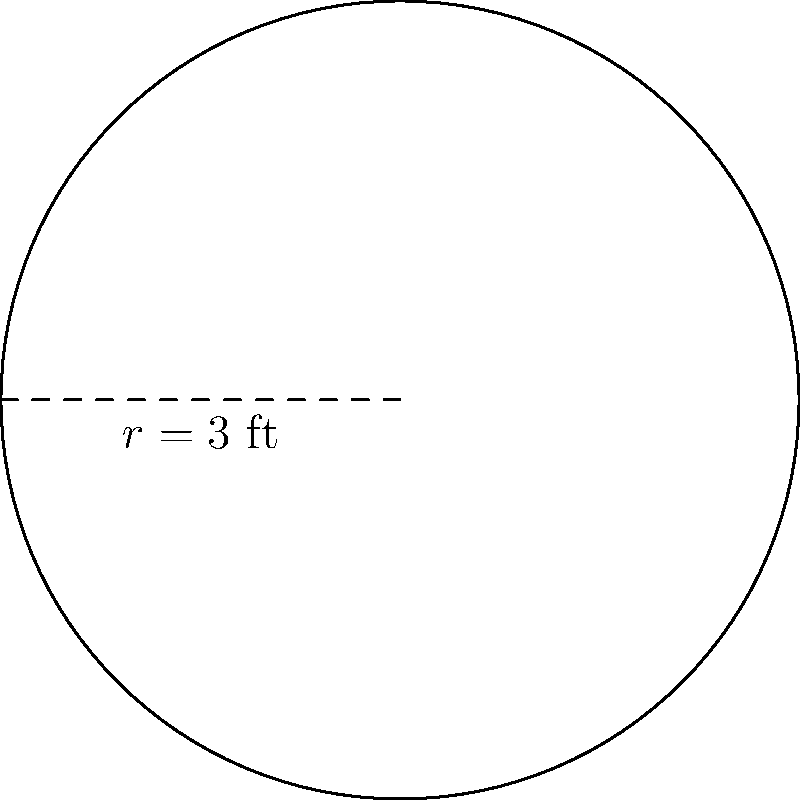As the community center staff member, you need to determine the area of a circular table for the English language classroom. The table has a radius of 3 feet. Calculate the area of the table in square feet, using $\pi \approx 3.14$. To find the area of a circular table, we'll use the formula for the area of a circle:

1. The formula for the area of a circle is:
   $A = \pi r^2$

2. We're given that the radius $r = 3$ feet and $\pi \approx 3.14$

3. Let's substitute these values into the formula:
   $A = 3.14 \times 3^2$

4. Calculate the square of the radius:
   $A = 3.14 \times 9$

5. Multiply:
   $A = 28.26$ square feet

Therefore, the area of the circular table is approximately 28.26 square feet.
Answer: $28.26$ sq ft 